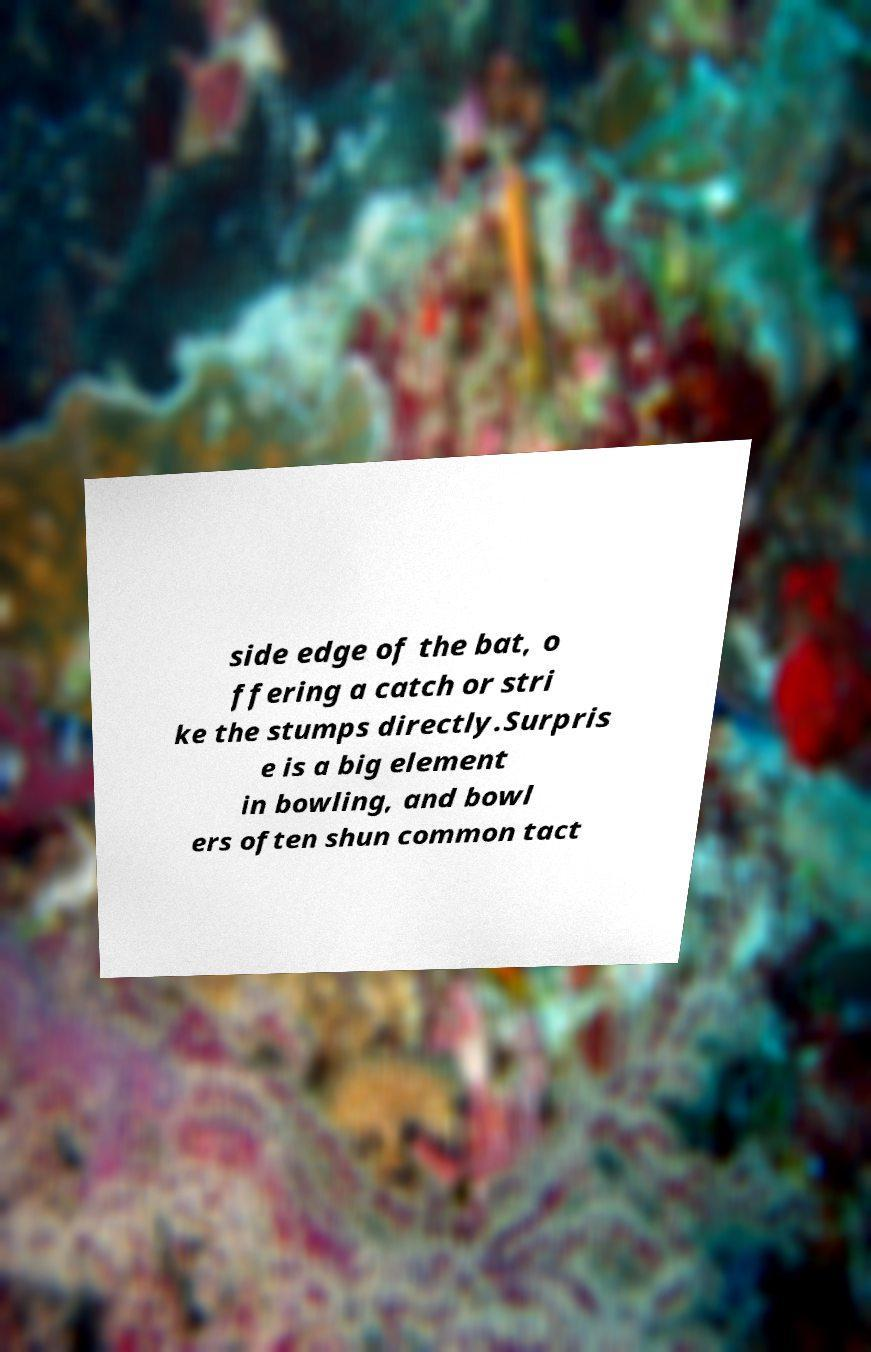I need the written content from this picture converted into text. Can you do that? side edge of the bat, o ffering a catch or stri ke the stumps directly.Surpris e is a big element in bowling, and bowl ers often shun common tact 